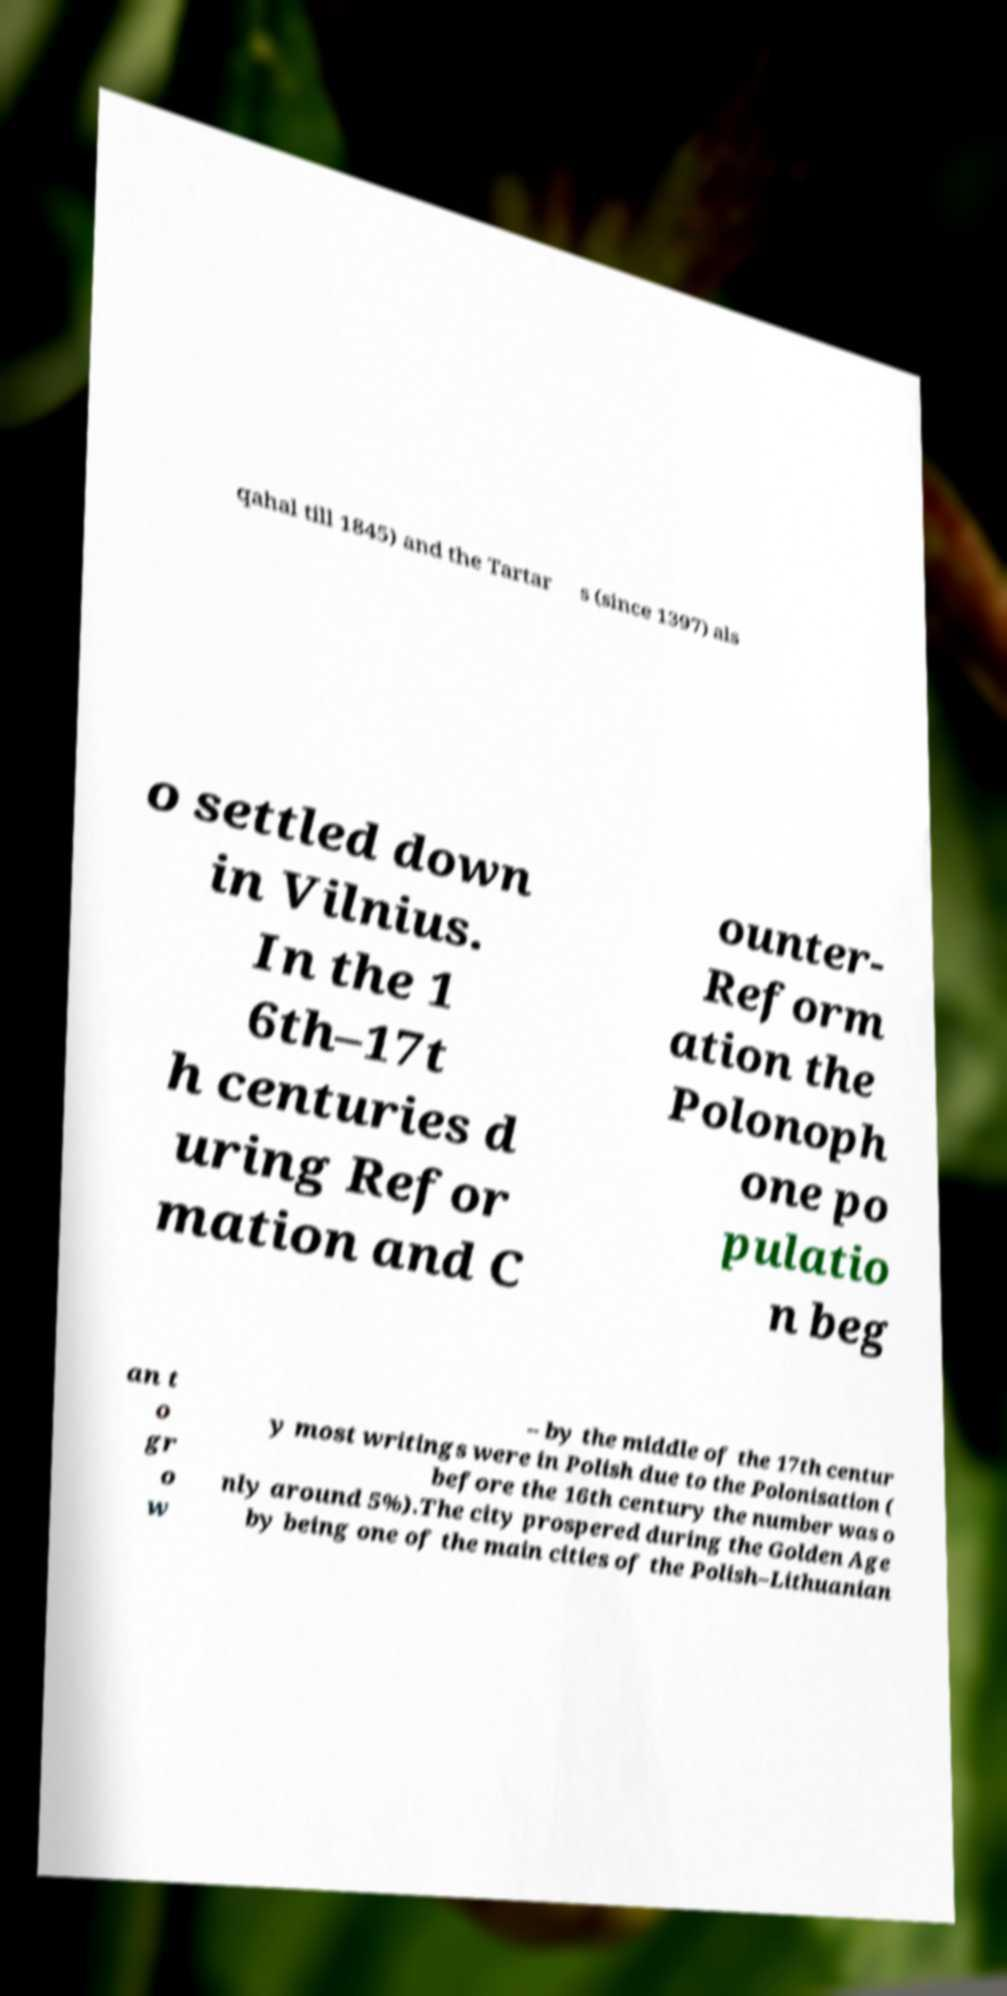Can you read and provide the text displayed in the image?This photo seems to have some interesting text. Can you extract and type it out for me? qahal till 1845) and the Tartar s (since 1397) als o settled down in Vilnius. In the 1 6th–17t h centuries d uring Refor mation and C ounter- Reform ation the Polonoph one po pulatio n beg an t o gr o w – by the middle of the 17th centur y most writings were in Polish due to the Polonisation ( before the 16th century the number was o nly around 5%).The city prospered during the Golden Age by being one of the main cities of the Polish–Lithuanian 